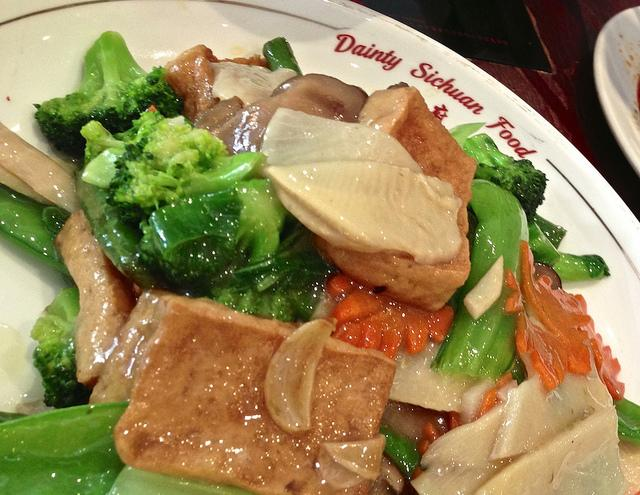What kind of cuisine is being served? Please explain your reasoning. chinese. Vegetables are on a plate. with chunks of meat. stir fry is a chinese dish. 